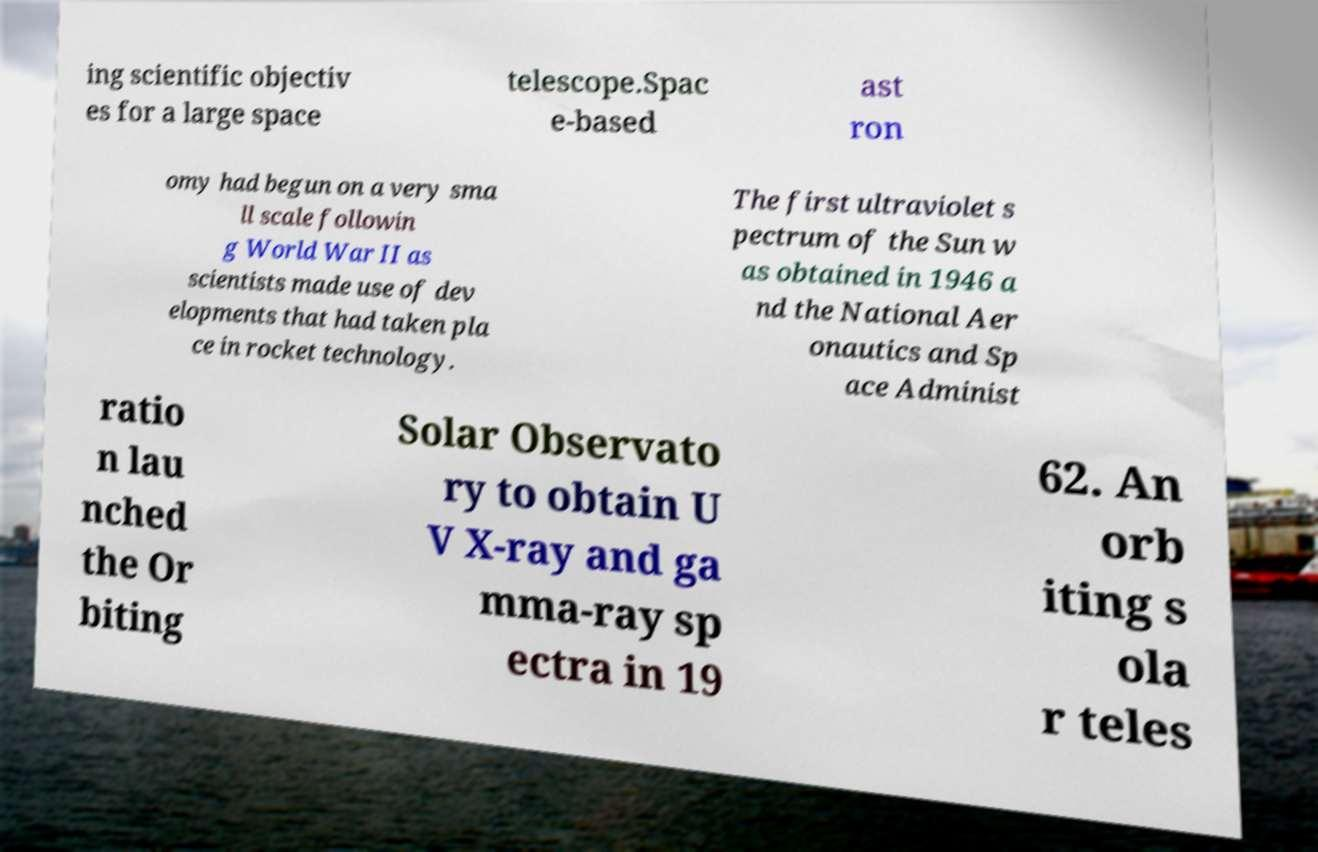Could you assist in decoding the text presented in this image and type it out clearly? ing scientific objectiv es for a large space telescope.Spac e-based ast ron omy had begun on a very sma ll scale followin g World War II as scientists made use of dev elopments that had taken pla ce in rocket technology. The first ultraviolet s pectrum of the Sun w as obtained in 1946 a nd the National Aer onautics and Sp ace Administ ratio n lau nched the Or biting Solar Observato ry to obtain U V X-ray and ga mma-ray sp ectra in 19 62. An orb iting s ola r teles 